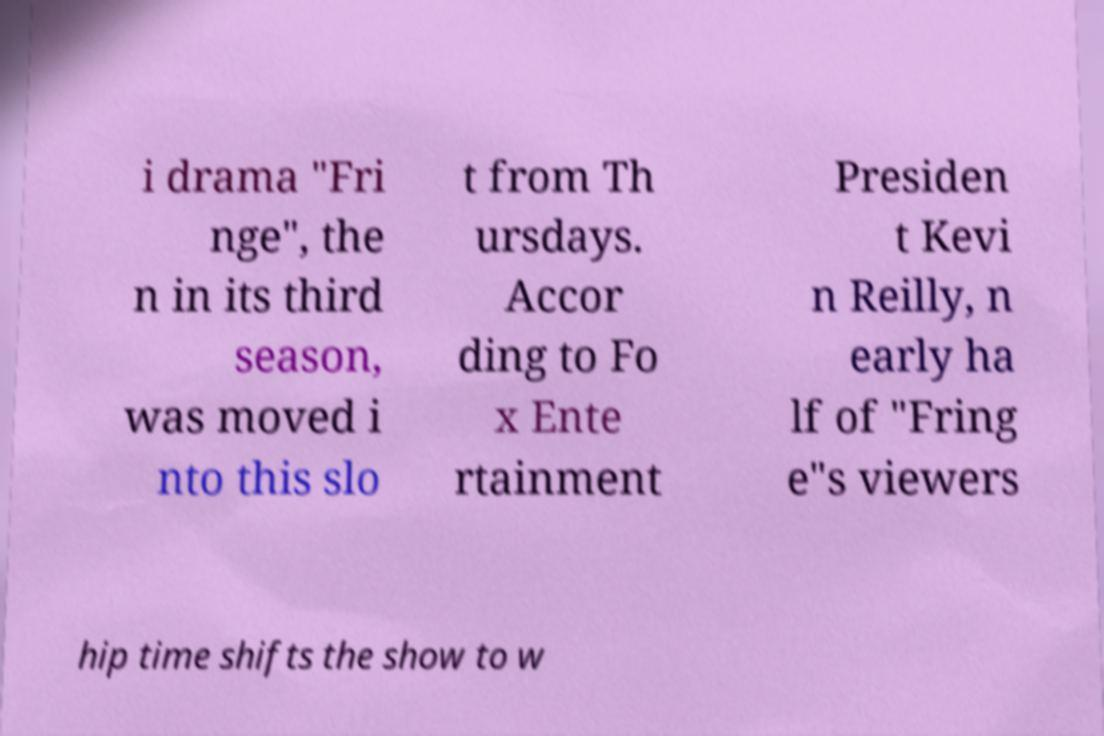Can you read and provide the text displayed in the image?This photo seems to have some interesting text. Can you extract and type it out for me? i drama "Fri nge", the n in its third season, was moved i nto this slo t from Th ursdays. Accor ding to Fo x Ente rtainment Presiden t Kevi n Reilly, n early ha lf of "Fring e"s viewers hip time shifts the show to w 